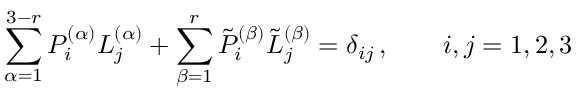<formula> <loc_0><loc_0><loc_500><loc_500>\sum _ { \alpha = 1 } ^ { 3 - r } { P } _ { i } ^ { ( \alpha ) } { L } _ { j } ^ { ( \alpha ) } + \sum _ { \beta = 1 } ^ { r } { \tilde { P } } _ { i } ^ { ( \beta ) } { \tilde { L } } _ { j } ^ { ( \beta ) } = \delta _ { i j } \, , \quad i , j = 1 , 2 , 3</formula> 